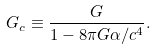<formula> <loc_0><loc_0><loc_500><loc_500>G _ { c } \equiv \frac { G } { 1 - 8 \pi G \alpha / c ^ { 4 } } .</formula> 